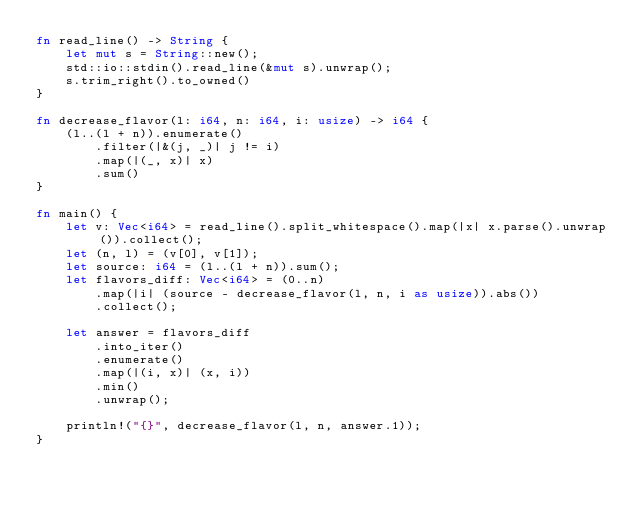Convert code to text. <code><loc_0><loc_0><loc_500><loc_500><_Rust_>fn read_line() -> String {
    let mut s = String::new();
    std::io::stdin().read_line(&mut s).unwrap();
    s.trim_right().to_owned()
}

fn decrease_flavor(l: i64, n: i64, i: usize) -> i64 {
    (l..(l + n)).enumerate()
        .filter(|&(j, _)| j != i)
        .map(|(_, x)| x)
        .sum()
}

fn main() {
    let v: Vec<i64> = read_line().split_whitespace().map(|x| x.parse().unwrap()).collect();
    let (n, l) = (v[0], v[1]);
    let source: i64 = (l..(l + n)).sum();
    let flavors_diff: Vec<i64> = (0..n)
        .map(|i| (source - decrease_flavor(l, n, i as usize)).abs())
        .collect();

    let answer = flavors_diff
        .into_iter()
        .enumerate()
        .map(|(i, x)| (x, i))
        .min()
        .unwrap();
    
    println!("{}", decrease_flavor(l, n, answer.1));
}
</code> 